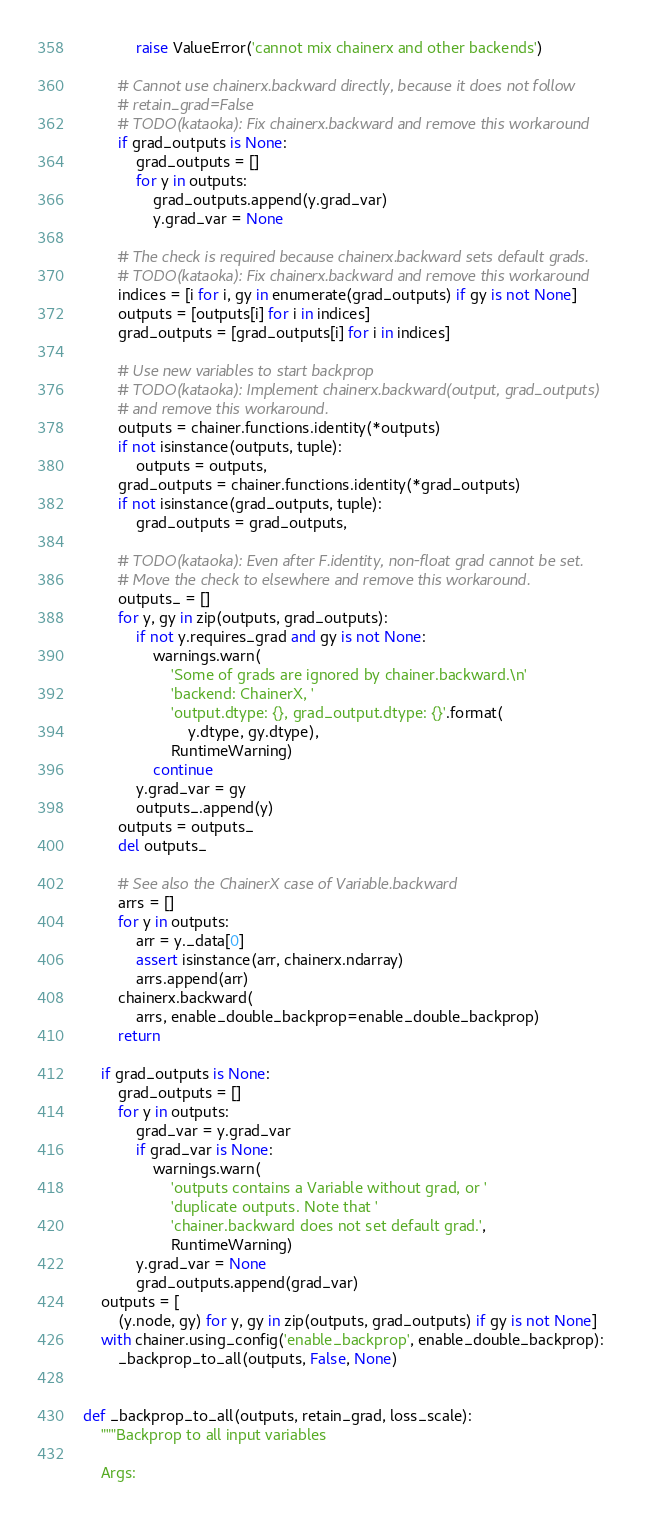<code> <loc_0><loc_0><loc_500><loc_500><_Python_>            raise ValueError('cannot mix chainerx and other backends')

        # Cannot use chainerx.backward directly, because it does not follow
        # retain_grad=False
        # TODO(kataoka): Fix chainerx.backward and remove this workaround
        if grad_outputs is None:
            grad_outputs = []
            for y in outputs:
                grad_outputs.append(y.grad_var)
                y.grad_var = None

        # The check is required because chainerx.backward sets default grads.
        # TODO(kataoka): Fix chainerx.backward and remove this workaround
        indices = [i for i, gy in enumerate(grad_outputs) if gy is not None]
        outputs = [outputs[i] for i in indices]
        grad_outputs = [grad_outputs[i] for i in indices]

        # Use new variables to start backprop
        # TODO(kataoka): Implement chainerx.backward(output, grad_outputs)
        # and remove this workaround.
        outputs = chainer.functions.identity(*outputs)
        if not isinstance(outputs, tuple):
            outputs = outputs,
        grad_outputs = chainer.functions.identity(*grad_outputs)
        if not isinstance(grad_outputs, tuple):
            grad_outputs = grad_outputs,

        # TODO(kataoka): Even after F.identity, non-float grad cannot be set.
        # Move the check to elsewhere and remove this workaround.
        outputs_ = []
        for y, gy in zip(outputs, grad_outputs):
            if not y.requires_grad and gy is not None:
                warnings.warn(
                    'Some of grads are ignored by chainer.backward.\n'
                    'backend: ChainerX, '
                    'output.dtype: {}, grad_output.dtype: {}'.format(
                        y.dtype, gy.dtype),
                    RuntimeWarning)
                continue
            y.grad_var = gy
            outputs_.append(y)
        outputs = outputs_
        del outputs_

        # See also the ChainerX case of Variable.backward
        arrs = []
        for y in outputs:
            arr = y._data[0]
            assert isinstance(arr, chainerx.ndarray)
            arrs.append(arr)
        chainerx.backward(
            arrs, enable_double_backprop=enable_double_backprop)
        return

    if grad_outputs is None:
        grad_outputs = []
        for y in outputs:
            grad_var = y.grad_var
            if grad_var is None:
                warnings.warn(
                    'outputs contains a Variable without grad, or '
                    'duplicate outputs. Note that '
                    'chainer.backward does not set default grad.',
                    RuntimeWarning)
            y.grad_var = None
            grad_outputs.append(grad_var)
    outputs = [
        (y.node, gy) for y, gy in zip(outputs, grad_outputs) if gy is not None]
    with chainer.using_config('enable_backprop', enable_double_backprop):
        _backprop_to_all(outputs, False, None)


def _backprop_to_all(outputs, retain_grad, loss_scale):
    """Backprop to all input variables

    Args:</code> 